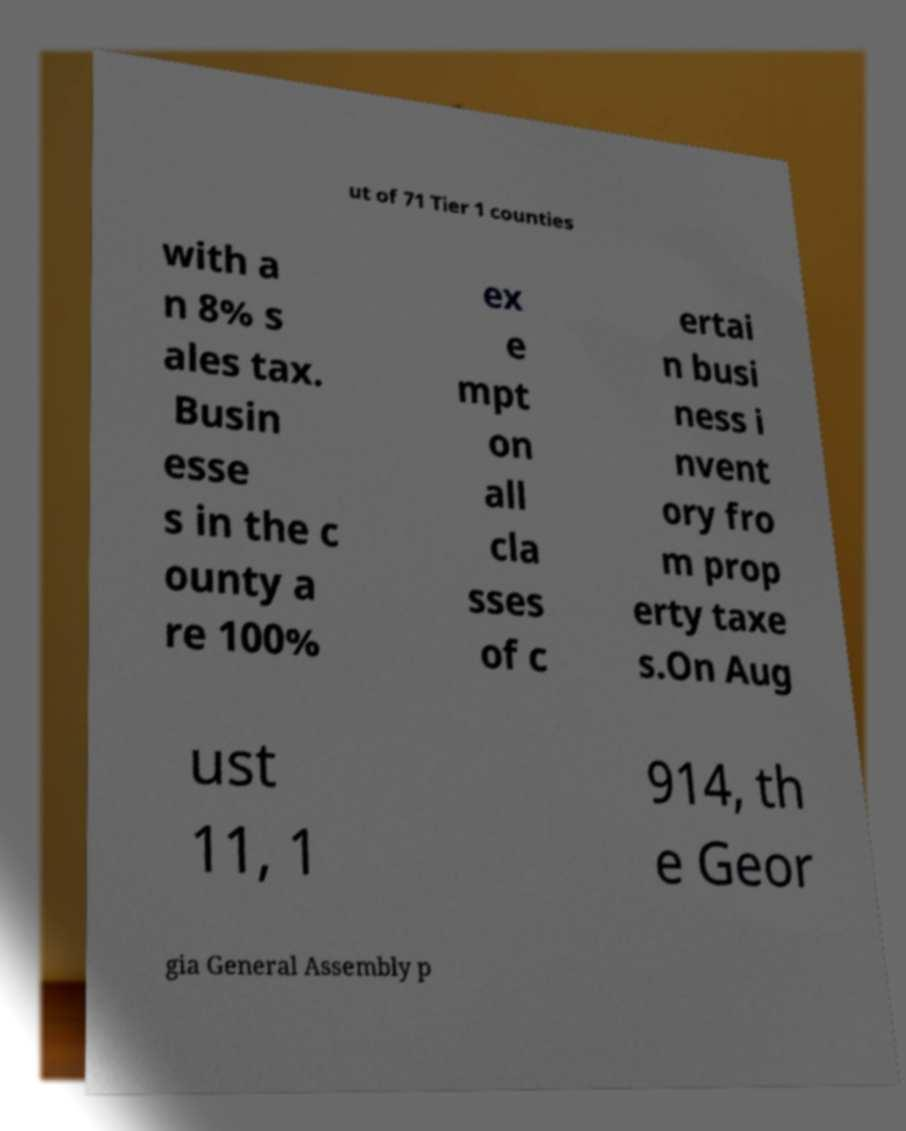Could you assist in decoding the text presented in this image and type it out clearly? ut of 71 Tier 1 counties with a n 8% s ales tax. Busin esse s in the c ounty a re 100% ex e mpt on all cla sses of c ertai n busi ness i nvent ory fro m prop erty taxe s.On Aug ust 11, 1 914, th e Geor gia General Assembly p 